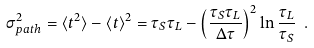Convert formula to latex. <formula><loc_0><loc_0><loc_500><loc_500>\sigma _ { p a t h } ^ { 2 } = \langle t ^ { 2 } \rangle - \langle t \rangle ^ { 2 } = \tau _ { S } \tau _ { L } - \left ( \frac { \tau _ { S } \tau _ { L } } { \Delta \tau } \right ) ^ { 2 } \ln { \frac { \tau _ { L } } { \tau _ { S } } } \ .</formula> 